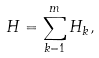<formula> <loc_0><loc_0><loc_500><loc_500>H = \sum _ { k = 1 } ^ { m } H _ { k } ,</formula> 